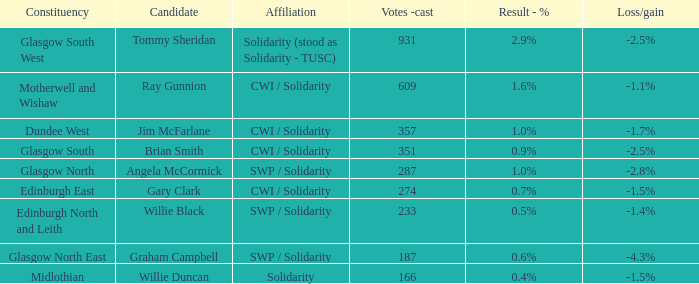Who was the candidate when the result - % was 0.4%? Willie Duncan. 